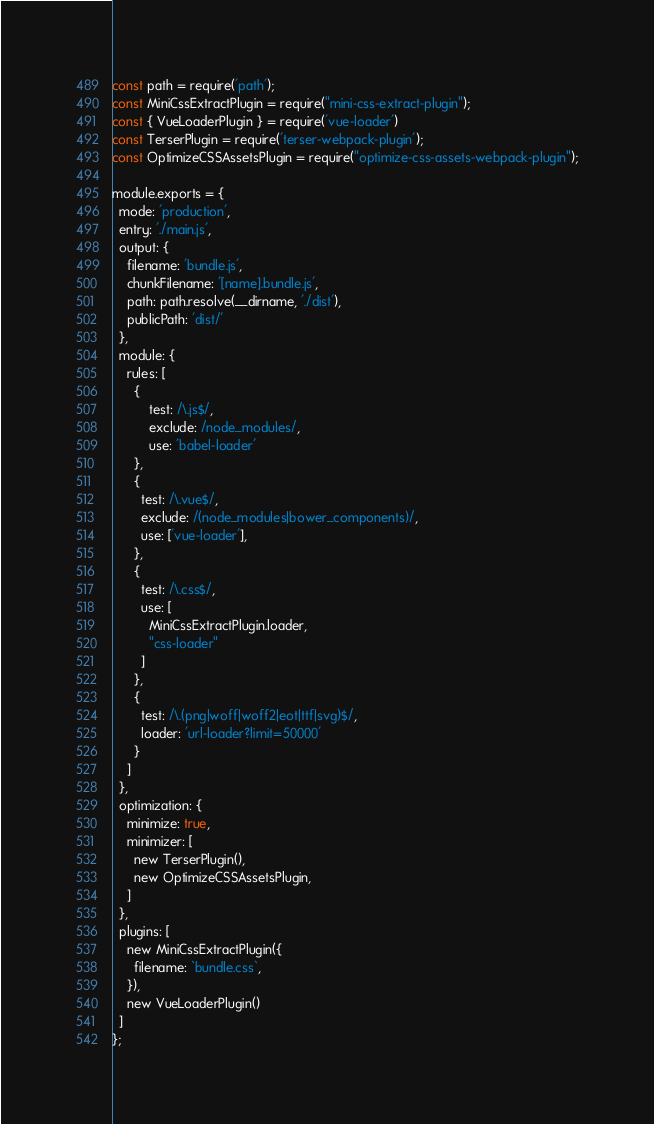Convert code to text. <code><loc_0><loc_0><loc_500><loc_500><_JavaScript_>const path = require('path');
const MiniCssExtractPlugin = require("mini-css-extract-plugin");
const { VueLoaderPlugin } = require('vue-loader')
const TerserPlugin = require('terser-webpack-plugin');
const OptimizeCSSAssetsPlugin = require("optimize-css-assets-webpack-plugin");

module.exports = {
  mode: 'production',
  entry: './main.js',
  output: {
    filename: 'bundle.js',
    chunkFilename: '[name].bundle.js',
    path: path.resolve(__dirname, './dist'),
    publicPath: 'dist/'
  },
  module: {
    rules: [
      {
          test: /\.js$/,
          exclude: /node_modules/,
          use: 'babel-loader'
      },
      {
        test: /\.vue$/,
        exclude: /(node_modules|bower_components)/,
        use: ['vue-loader'],
      },
      {
        test: /\.css$/,
        use: [
          MiniCssExtractPlugin.loader,
          "css-loader"
        ]
      },
      {
        test: /\.(png|woff|woff2|eot|ttf|svg)$/,
        loader: 'url-loader?limit=50000'
      }
    ]
  },
  optimization: {
    minimize: true,
    minimizer: [
      new TerserPlugin(),
      new OptimizeCSSAssetsPlugin,
    ]
  },
  plugins: [
    new MiniCssExtractPlugin({
      filename: `bundle.css`,
    }),
    new VueLoaderPlugin()
  ]
};
</code> 